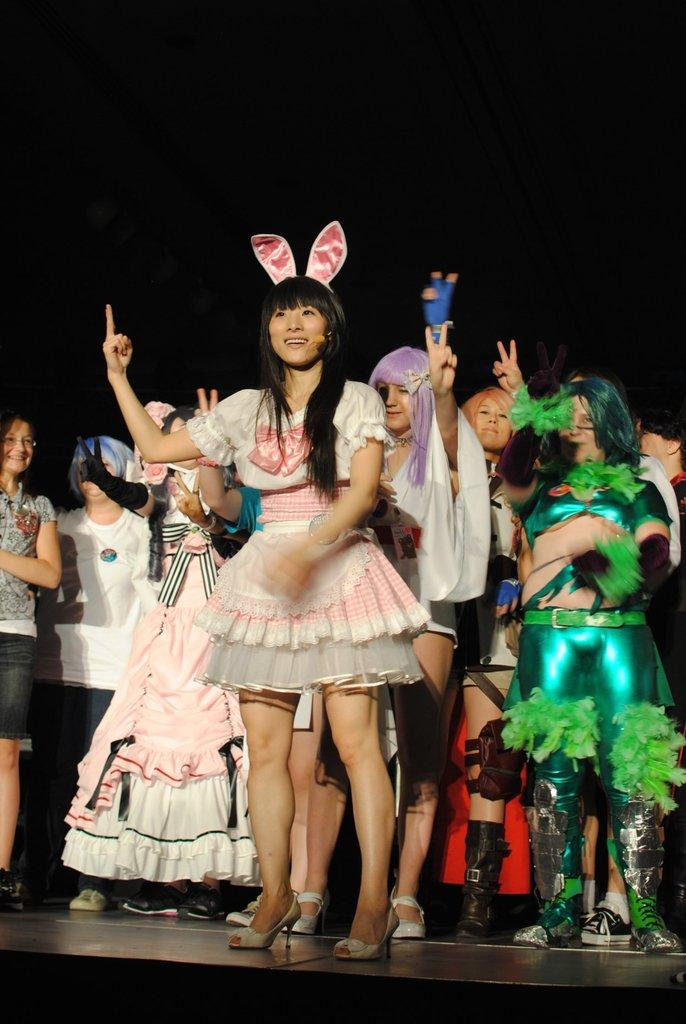What is happening in the image? There is a group of people in the image. Where are the people located? The people are on the floor. What can be observed about the background of the image? The background of the image is dark. What type of card is being used by the people in the image? There is no card present in the image; the people are simply on the floor. 